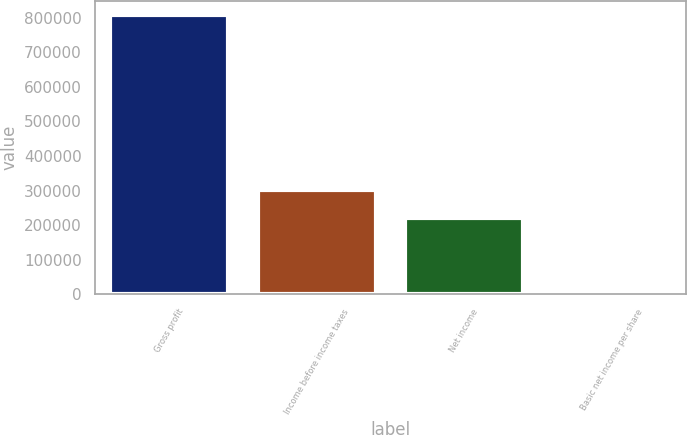Convert chart. <chart><loc_0><loc_0><loc_500><loc_500><bar_chart><fcel>Gross profit<fcel>Income before income taxes<fcel>Net income<fcel>Basic net income per share<nl><fcel>807970<fcel>300176<fcel>219379<fcel>0.39<nl></chart> 